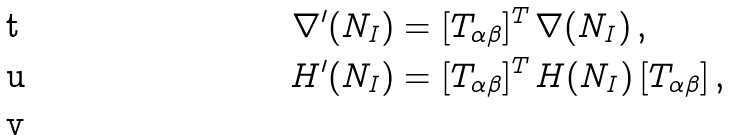Convert formula to latex. <formula><loc_0><loc_0><loc_500><loc_500>\nabla ^ { \prime } ( N _ { I } ) & = [ T _ { \alpha \beta } ] ^ { T } \, \nabla ( N _ { I } ) \, , \\ H ^ { \prime } ( N _ { I } ) & = [ T _ { \alpha \beta } ] ^ { T } \, H ( N _ { I } ) \, [ T _ { \alpha \beta } ] \, , \\</formula> 